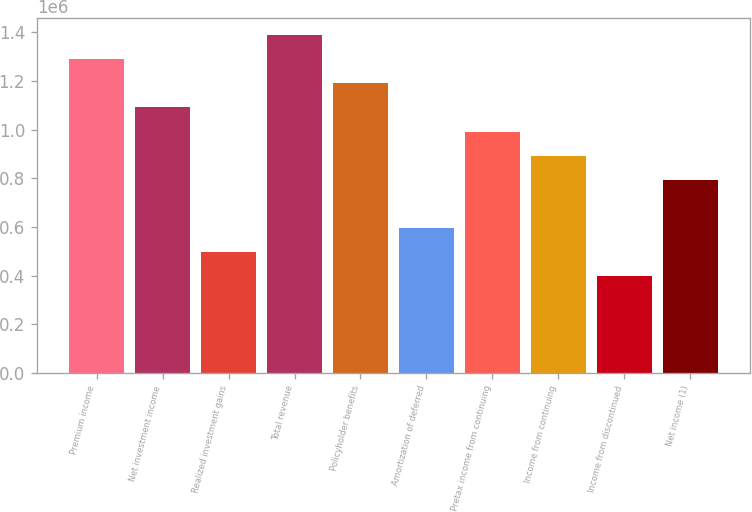<chart> <loc_0><loc_0><loc_500><loc_500><bar_chart><fcel>Premium income<fcel>Net investment income<fcel>Realized investment gains<fcel>Total revenue<fcel>Policyholder benefits<fcel>Amortization of deferred<fcel>Pretax income from continuing<fcel>Income from continuing<fcel>Income from discontinued<fcel>Net income (1)<nl><fcel>1.28945e+06<fcel>1.09107e+06<fcel>495942<fcel>1.38864e+06<fcel>1.19026e+06<fcel>595130<fcel>991884<fcel>892696<fcel>396754<fcel>793507<nl></chart> 